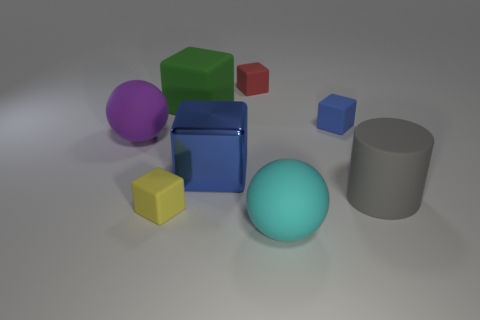Are there any other things that have the same material as the large blue cube?
Provide a short and direct response. No. Are there fewer purple matte things than small blue matte balls?
Provide a succinct answer. No. The large ball left of the big matte thing behind the small rubber thing right of the big cyan object is made of what material?
Offer a very short reply. Rubber. What is the material of the gray cylinder?
Ensure brevity in your answer.  Rubber. There is a small rubber cube that is right of the tiny red block; is its color the same as the big cube that is right of the big green cube?
Your answer should be very brief. Yes. Is the number of gray cylinders greater than the number of large yellow shiny cylinders?
Give a very brief answer. Yes. What number of objects are the same color as the rubber cylinder?
Your answer should be compact. 0. There is another thing that is the same shape as the purple object; what color is it?
Offer a terse response. Cyan. There is a object that is both in front of the big purple object and behind the big matte cylinder; what material is it made of?
Offer a terse response. Metal. Are the blue thing in front of the purple rubber object and the tiny cube on the left side of the large metal block made of the same material?
Ensure brevity in your answer.  No. 